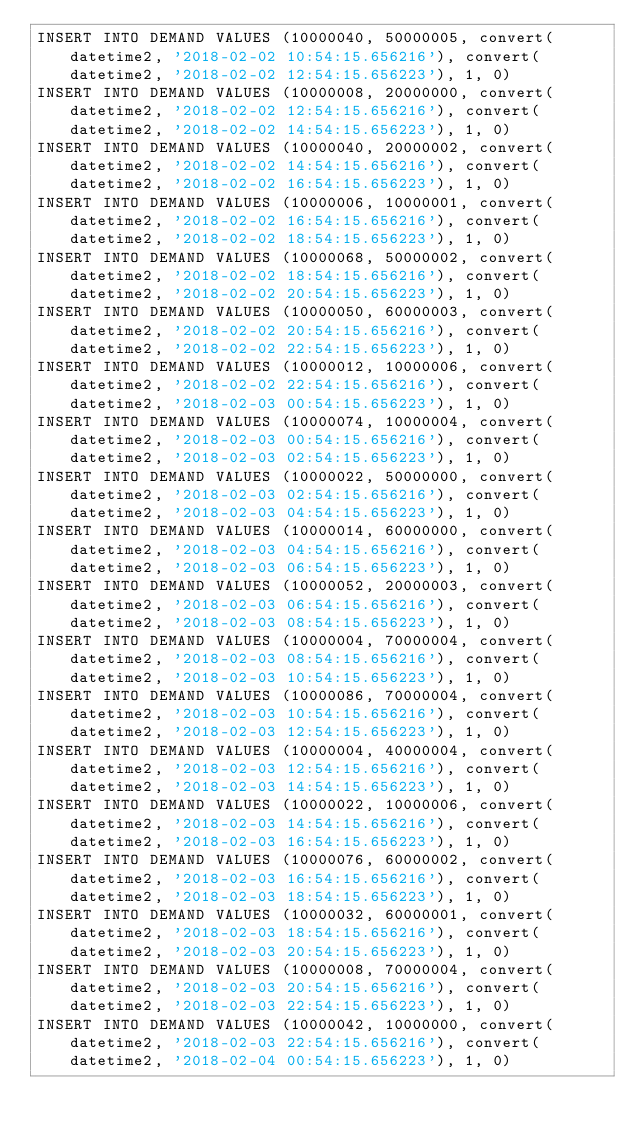Convert code to text. <code><loc_0><loc_0><loc_500><loc_500><_SQL_>INSERT INTO DEMAND VALUES (10000040, 50000005, convert(datetime2, '2018-02-02 10:54:15.656216'), convert(datetime2, '2018-02-02 12:54:15.656223'), 1, 0)
INSERT INTO DEMAND VALUES (10000008, 20000000, convert(datetime2, '2018-02-02 12:54:15.656216'), convert(datetime2, '2018-02-02 14:54:15.656223'), 1, 0)
INSERT INTO DEMAND VALUES (10000040, 20000002, convert(datetime2, '2018-02-02 14:54:15.656216'), convert(datetime2, '2018-02-02 16:54:15.656223'), 1, 0)
INSERT INTO DEMAND VALUES (10000006, 10000001, convert(datetime2, '2018-02-02 16:54:15.656216'), convert(datetime2, '2018-02-02 18:54:15.656223'), 1, 0)
INSERT INTO DEMAND VALUES (10000068, 50000002, convert(datetime2, '2018-02-02 18:54:15.656216'), convert(datetime2, '2018-02-02 20:54:15.656223'), 1, 0)
INSERT INTO DEMAND VALUES (10000050, 60000003, convert(datetime2, '2018-02-02 20:54:15.656216'), convert(datetime2, '2018-02-02 22:54:15.656223'), 1, 0)
INSERT INTO DEMAND VALUES (10000012, 10000006, convert(datetime2, '2018-02-02 22:54:15.656216'), convert(datetime2, '2018-02-03 00:54:15.656223'), 1, 0)
INSERT INTO DEMAND VALUES (10000074, 10000004, convert(datetime2, '2018-02-03 00:54:15.656216'), convert(datetime2, '2018-02-03 02:54:15.656223'), 1, 0)
INSERT INTO DEMAND VALUES (10000022, 50000000, convert(datetime2, '2018-02-03 02:54:15.656216'), convert(datetime2, '2018-02-03 04:54:15.656223'), 1, 0)
INSERT INTO DEMAND VALUES (10000014, 60000000, convert(datetime2, '2018-02-03 04:54:15.656216'), convert(datetime2, '2018-02-03 06:54:15.656223'), 1, 0)
INSERT INTO DEMAND VALUES (10000052, 20000003, convert(datetime2, '2018-02-03 06:54:15.656216'), convert(datetime2, '2018-02-03 08:54:15.656223'), 1, 0)
INSERT INTO DEMAND VALUES (10000004, 70000004, convert(datetime2, '2018-02-03 08:54:15.656216'), convert(datetime2, '2018-02-03 10:54:15.656223'), 1, 0)
INSERT INTO DEMAND VALUES (10000086, 70000004, convert(datetime2, '2018-02-03 10:54:15.656216'), convert(datetime2, '2018-02-03 12:54:15.656223'), 1, 0)
INSERT INTO DEMAND VALUES (10000004, 40000004, convert(datetime2, '2018-02-03 12:54:15.656216'), convert(datetime2, '2018-02-03 14:54:15.656223'), 1, 0)
INSERT INTO DEMAND VALUES (10000022, 10000006, convert(datetime2, '2018-02-03 14:54:15.656216'), convert(datetime2, '2018-02-03 16:54:15.656223'), 1, 0)
INSERT INTO DEMAND VALUES (10000076, 60000002, convert(datetime2, '2018-02-03 16:54:15.656216'), convert(datetime2, '2018-02-03 18:54:15.656223'), 1, 0)
INSERT INTO DEMAND VALUES (10000032, 60000001, convert(datetime2, '2018-02-03 18:54:15.656216'), convert(datetime2, '2018-02-03 20:54:15.656223'), 1, 0)
INSERT INTO DEMAND VALUES (10000008, 70000004, convert(datetime2, '2018-02-03 20:54:15.656216'), convert(datetime2, '2018-02-03 22:54:15.656223'), 1, 0)
INSERT INTO DEMAND VALUES (10000042, 10000000, convert(datetime2, '2018-02-03 22:54:15.656216'), convert(datetime2, '2018-02-04 00:54:15.656223'), 1, 0)</code> 